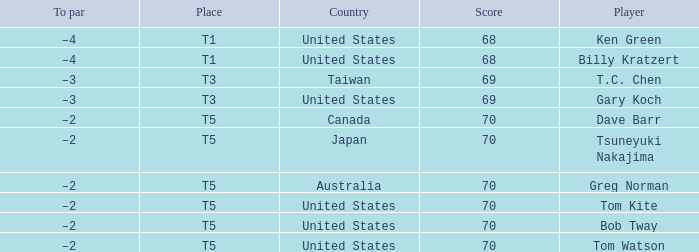What is the lowest score that Bob Tway get when he placed t5? 70.0. 